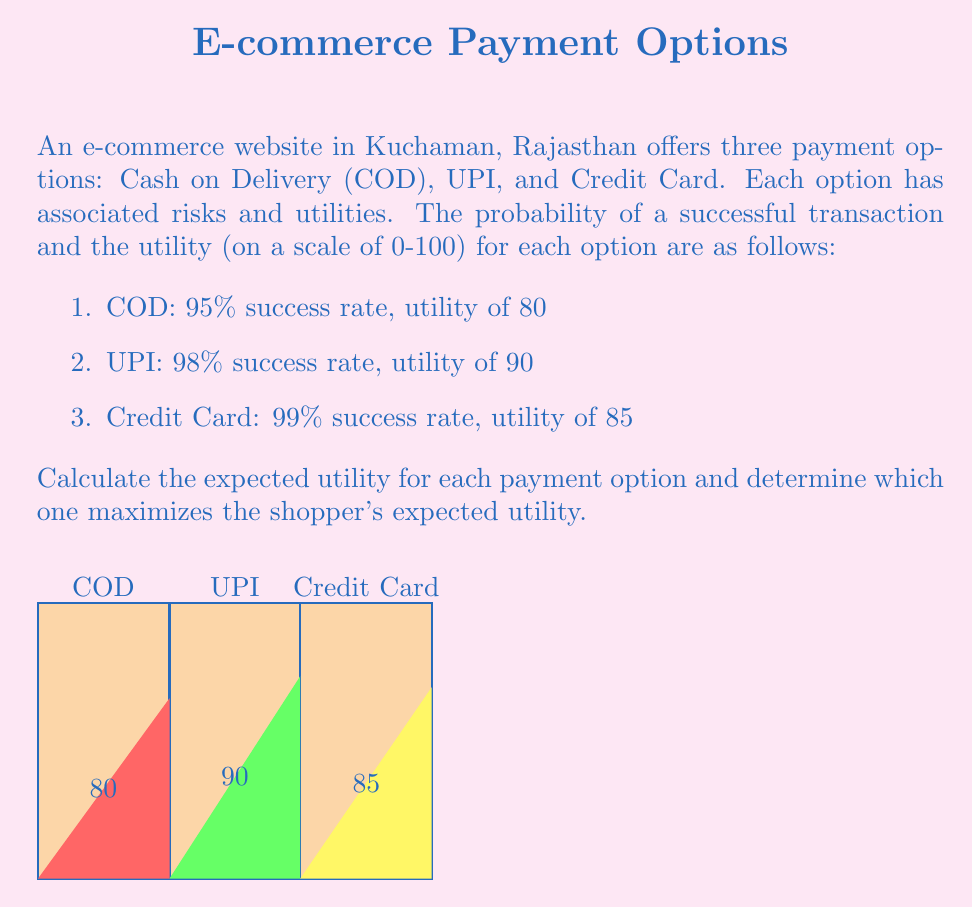Solve this math problem. To solve this problem, we need to calculate the expected utility for each payment option using the formula:

Expected Utility = Probability of Success × Utility

Let's calculate for each option:

1. Cash on Delivery (COD):
   Expected Utility = 0.95 × 80 = 76

2. UPI:
   Expected Utility = 0.98 × 90 = 88.2

3. Credit Card:
   Expected Utility = 0.99 × 85 = 84.15

Now, let's compare the expected utilities:

$$\begin{align}
\text{COD} &: 76 \\
\text{UPI} &: 88.2 \\
\text{Credit Card} &: 84.15
\end{align}$$

The payment option with the highest expected utility is UPI with 88.2.

To formalize this decision, we can use the principle of maximizing expected utility in decision theory. Let $A$ be the set of actions (payment options) and $EU(a)$ be the expected utility of action $a$. The optimal decision $a^*$ is given by:

$$a^* = \arg\max_{a \in A} EU(a)$$

In this case, $a^* = \text{UPI}$ since it has the highest expected utility.
Answer: UPI maximizes expected utility with 88.2. 